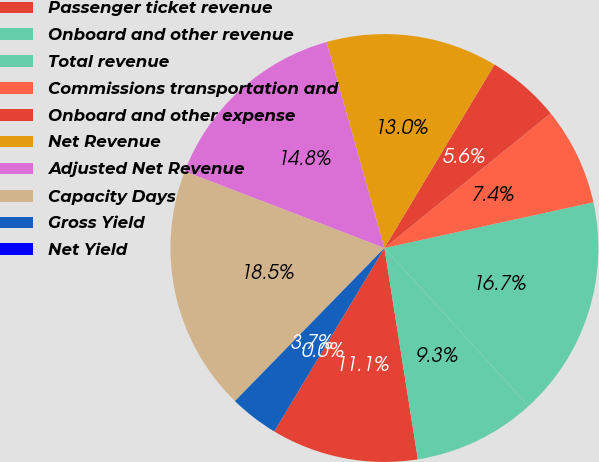Convert chart. <chart><loc_0><loc_0><loc_500><loc_500><pie_chart><fcel>Passenger ticket revenue<fcel>Onboard and other revenue<fcel>Total revenue<fcel>Commissions transportation and<fcel>Onboard and other expense<fcel>Net Revenue<fcel>Adjusted Net Revenue<fcel>Capacity Days<fcel>Gross Yield<fcel>Net Yield<nl><fcel>11.11%<fcel>9.26%<fcel>16.67%<fcel>7.41%<fcel>5.56%<fcel>12.96%<fcel>14.81%<fcel>18.52%<fcel>3.7%<fcel>0.0%<nl></chart> 